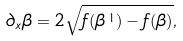<formula> <loc_0><loc_0><loc_500><loc_500>\partial _ { x } \beta = 2 \sqrt { f ( \beta ^ { \, 1 } ) - f ( \beta ) } ,</formula> 